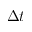Convert formula to latex. <formula><loc_0><loc_0><loc_500><loc_500>\Delta t</formula> 